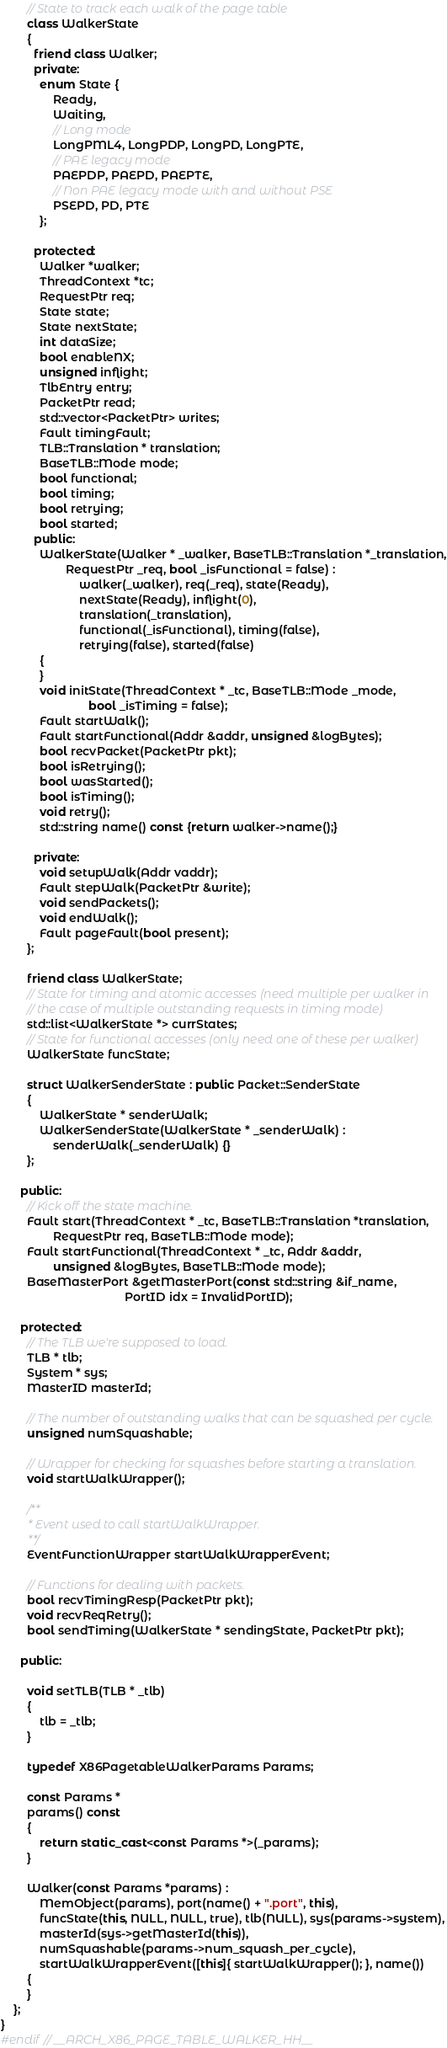Convert code to text. <code><loc_0><loc_0><loc_500><loc_500><_C++_>
        // State to track each walk of the page table
        class WalkerState
        {
          friend class Walker;
          private:
            enum State {
                Ready,
                Waiting,
                // Long mode
                LongPML4, LongPDP, LongPD, LongPTE,
                // PAE legacy mode
                PAEPDP, PAEPD, PAEPTE,
                // Non PAE legacy mode with and without PSE
                PSEPD, PD, PTE
            };

          protected:
            Walker *walker;
            ThreadContext *tc;
            RequestPtr req;
            State state;
            State nextState;
            int dataSize;
            bool enableNX;
            unsigned inflight;
            TlbEntry entry;
            PacketPtr read;
            std::vector<PacketPtr> writes;
            Fault timingFault;
            TLB::Translation * translation;
            BaseTLB::Mode mode;
            bool functional;
            bool timing;
            bool retrying;
            bool started;
          public:
            WalkerState(Walker * _walker, BaseTLB::Translation *_translation,
                    RequestPtr _req, bool _isFunctional = false) :
                        walker(_walker), req(_req), state(Ready),
                        nextState(Ready), inflight(0),
                        translation(_translation),
                        functional(_isFunctional), timing(false),
                        retrying(false), started(false)
            {
            }
            void initState(ThreadContext * _tc, BaseTLB::Mode _mode,
                           bool _isTiming = false);
            Fault startWalk();
            Fault startFunctional(Addr &addr, unsigned &logBytes);
            bool recvPacket(PacketPtr pkt);
            bool isRetrying();
            bool wasStarted();
            bool isTiming();
            void retry();
            std::string name() const {return walker->name();}

          private:
            void setupWalk(Addr vaddr);
            Fault stepWalk(PacketPtr &write);
            void sendPackets();
            void endWalk();
            Fault pageFault(bool present);
        };

        friend class WalkerState;
        // State for timing and atomic accesses (need multiple per walker in
        // the case of multiple outstanding requests in timing mode)
        std::list<WalkerState *> currStates;
        // State for functional accesses (only need one of these per walker)
        WalkerState funcState;

        struct WalkerSenderState : public Packet::SenderState
        {
            WalkerState * senderWalk;
            WalkerSenderState(WalkerState * _senderWalk) :
                senderWalk(_senderWalk) {}
        };

      public:
        // Kick off the state machine.
        Fault start(ThreadContext * _tc, BaseTLB::Translation *translation,
                RequestPtr req, BaseTLB::Mode mode);
        Fault startFunctional(ThreadContext * _tc, Addr &addr,
                unsigned &logBytes, BaseTLB::Mode mode);
        BaseMasterPort &getMasterPort(const std::string &if_name,
                                      PortID idx = InvalidPortID);

      protected:
        // The TLB we're supposed to load.
        TLB * tlb;
        System * sys;
        MasterID masterId;

        // The number of outstanding walks that can be squashed per cycle.
        unsigned numSquashable;

        // Wrapper for checking for squashes before starting a translation.
        void startWalkWrapper();

        /**
         * Event used to call startWalkWrapper.
         **/
        EventFunctionWrapper startWalkWrapperEvent;

        // Functions for dealing with packets.
        bool recvTimingResp(PacketPtr pkt);
        void recvReqRetry();
        bool sendTiming(WalkerState * sendingState, PacketPtr pkt);

      public:

        void setTLB(TLB * _tlb)
        {
            tlb = _tlb;
        }

        typedef X86PagetableWalkerParams Params;

        const Params *
        params() const
        {
            return static_cast<const Params *>(_params);
        }

        Walker(const Params *params) :
            MemObject(params), port(name() + ".port", this),
            funcState(this, NULL, NULL, true), tlb(NULL), sys(params->system),
            masterId(sys->getMasterId(this)),
            numSquashable(params->num_squash_per_cycle),
            startWalkWrapperEvent([this]{ startWalkWrapper(); }, name())
        {
        }
    };
}
#endif // __ARCH_X86_PAGE_TABLE_WALKER_HH__
</code> 